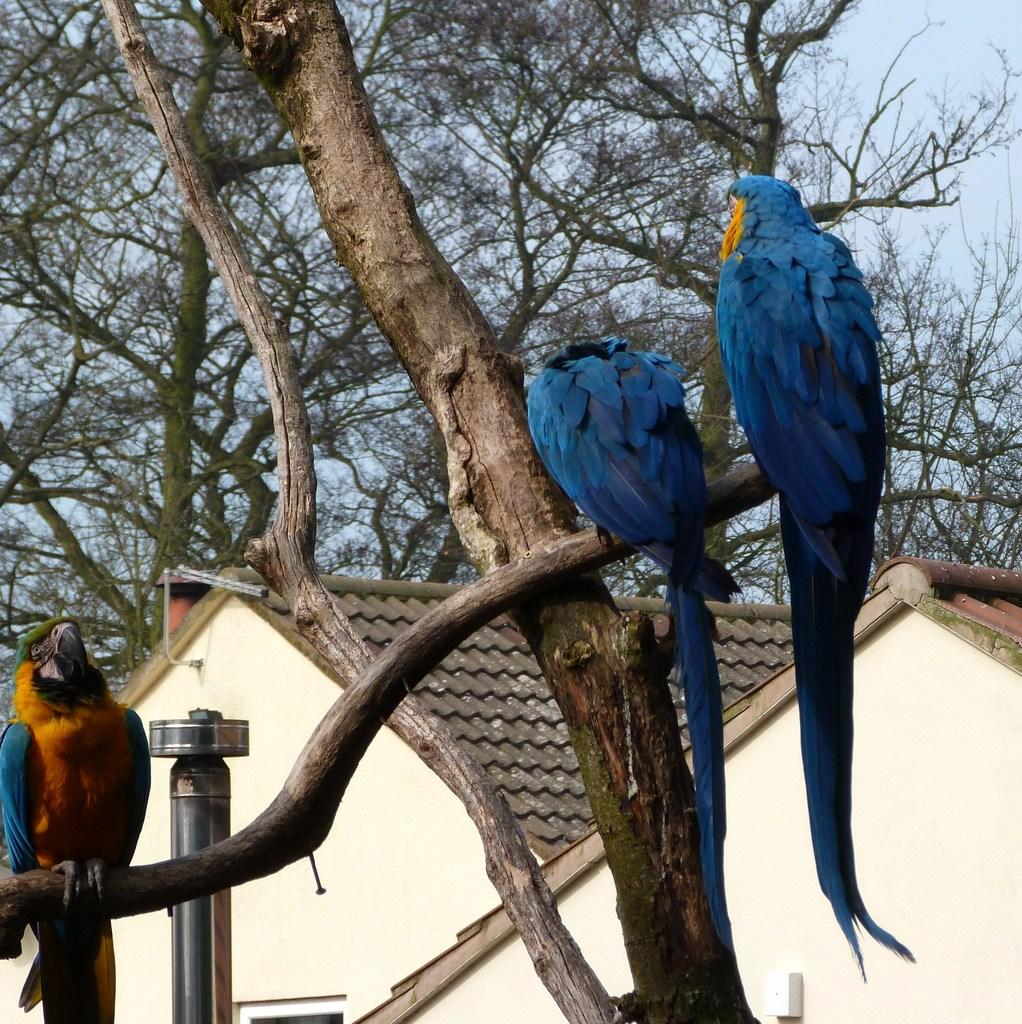How many birds are in the image? There are three birds in the image. Where are the birds located? The birds are standing on a tree branch. What can be seen on the left side of the image? There is a pole on the left side of the image. What is visible in the background of the image? There are two houses, trees, and the sky visible in the background of the image. What word is the pet bird saying in the image? There is no pet bird present in the image, and therefore no word can be attributed to a bird. 